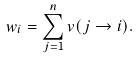<formula> <loc_0><loc_0><loc_500><loc_500>w _ { i } = \sum _ { j = 1 } ^ { n } v ( j \rightarrow i ) .</formula> 